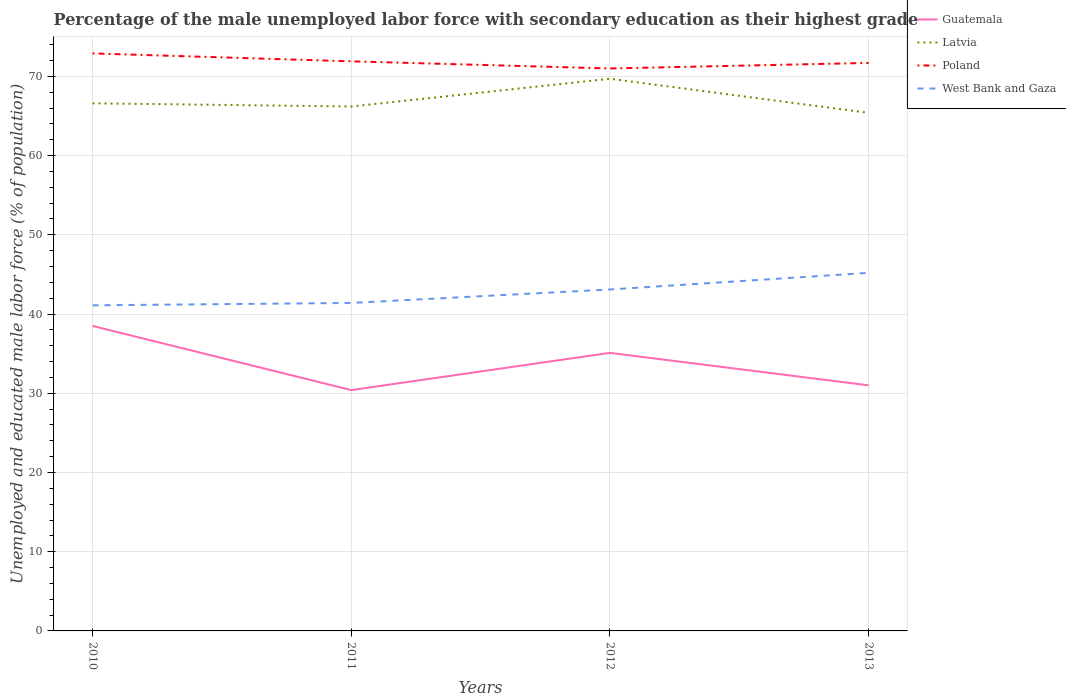Is the number of lines equal to the number of legend labels?
Offer a very short reply. Yes. Across all years, what is the maximum percentage of the unemployed male labor force with secondary education in Guatemala?
Your answer should be very brief. 30.4. What is the total percentage of the unemployed male labor force with secondary education in West Bank and Gaza in the graph?
Your answer should be very brief. -1.7. What is the difference between the highest and the second highest percentage of the unemployed male labor force with secondary education in Poland?
Provide a short and direct response. 1.9. What is the difference between the highest and the lowest percentage of the unemployed male labor force with secondary education in Guatemala?
Your answer should be compact. 2. How many lines are there?
Your answer should be very brief. 4. What is the difference between two consecutive major ticks on the Y-axis?
Provide a short and direct response. 10. Does the graph contain any zero values?
Keep it short and to the point. No. Does the graph contain grids?
Keep it short and to the point. Yes. How many legend labels are there?
Keep it short and to the point. 4. What is the title of the graph?
Your response must be concise. Percentage of the male unemployed labor force with secondary education as their highest grade. Does "Togo" appear as one of the legend labels in the graph?
Make the answer very short. No. What is the label or title of the X-axis?
Keep it short and to the point. Years. What is the label or title of the Y-axis?
Offer a terse response. Unemployed and educated male labor force (% of population). What is the Unemployed and educated male labor force (% of population) of Guatemala in 2010?
Provide a short and direct response. 38.5. What is the Unemployed and educated male labor force (% of population) in Latvia in 2010?
Provide a short and direct response. 66.6. What is the Unemployed and educated male labor force (% of population) of Poland in 2010?
Your response must be concise. 72.9. What is the Unemployed and educated male labor force (% of population) of West Bank and Gaza in 2010?
Make the answer very short. 41.1. What is the Unemployed and educated male labor force (% of population) in Guatemala in 2011?
Provide a succinct answer. 30.4. What is the Unemployed and educated male labor force (% of population) of Latvia in 2011?
Provide a succinct answer. 66.2. What is the Unemployed and educated male labor force (% of population) of Poland in 2011?
Offer a terse response. 71.9. What is the Unemployed and educated male labor force (% of population) of West Bank and Gaza in 2011?
Your answer should be compact. 41.4. What is the Unemployed and educated male labor force (% of population) in Guatemala in 2012?
Ensure brevity in your answer.  35.1. What is the Unemployed and educated male labor force (% of population) in Latvia in 2012?
Provide a short and direct response. 69.7. What is the Unemployed and educated male labor force (% of population) in Poland in 2012?
Make the answer very short. 71. What is the Unemployed and educated male labor force (% of population) of West Bank and Gaza in 2012?
Your answer should be compact. 43.1. What is the Unemployed and educated male labor force (% of population) in Latvia in 2013?
Offer a terse response. 65.4. What is the Unemployed and educated male labor force (% of population) of Poland in 2013?
Provide a succinct answer. 71.7. What is the Unemployed and educated male labor force (% of population) of West Bank and Gaza in 2013?
Give a very brief answer. 45.2. Across all years, what is the maximum Unemployed and educated male labor force (% of population) of Guatemala?
Offer a very short reply. 38.5. Across all years, what is the maximum Unemployed and educated male labor force (% of population) of Latvia?
Your answer should be compact. 69.7. Across all years, what is the maximum Unemployed and educated male labor force (% of population) of Poland?
Offer a terse response. 72.9. Across all years, what is the maximum Unemployed and educated male labor force (% of population) in West Bank and Gaza?
Offer a terse response. 45.2. Across all years, what is the minimum Unemployed and educated male labor force (% of population) in Guatemala?
Your response must be concise. 30.4. Across all years, what is the minimum Unemployed and educated male labor force (% of population) in Latvia?
Provide a short and direct response. 65.4. Across all years, what is the minimum Unemployed and educated male labor force (% of population) in West Bank and Gaza?
Keep it short and to the point. 41.1. What is the total Unemployed and educated male labor force (% of population) in Guatemala in the graph?
Keep it short and to the point. 135. What is the total Unemployed and educated male labor force (% of population) in Latvia in the graph?
Offer a very short reply. 267.9. What is the total Unemployed and educated male labor force (% of population) in Poland in the graph?
Provide a short and direct response. 287.5. What is the total Unemployed and educated male labor force (% of population) of West Bank and Gaza in the graph?
Your answer should be very brief. 170.8. What is the difference between the Unemployed and educated male labor force (% of population) of Poland in 2010 and that in 2011?
Provide a short and direct response. 1. What is the difference between the Unemployed and educated male labor force (% of population) in West Bank and Gaza in 2010 and that in 2011?
Your response must be concise. -0.3. What is the difference between the Unemployed and educated male labor force (% of population) of West Bank and Gaza in 2010 and that in 2012?
Your answer should be compact. -2. What is the difference between the Unemployed and educated male labor force (% of population) in Guatemala in 2010 and that in 2013?
Ensure brevity in your answer.  7.5. What is the difference between the Unemployed and educated male labor force (% of population) in Poland in 2010 and that in 2013?
Make the answer very short. 1.2. What is the difference between the Unemployed and educated male labor force (% of population) in West Bank and Gaza in 2010 and that in 2013?
Your answer should be very brief. -4.1. What is the difference between the Unemployed and educated male labor force (% of population) in Latvia in 2011 and that in 2012?
Offer a very short reply. -3.5. What is the difference between the Unemployed and educated male labor force (% of population) in West Bank and Gaza in 2011 and that in 2012?
Give a very brief answer. -1.7. What is the difference between the Unemployed and educated male labor force (% of population) in Poland in 2011 and that in 2013?
Your response must be concise. 0.2. What is the difference between the Unemployed and educated male labor force (% of population) in Guatemala in 2012 and that in 2013?
Make the answer very short. 4.1. What is the difference between the Unemployed and educated male labor force (% of population) of Poland in 2012 and that in 2013?
Provide a succinct answer. -0.7. What is the difference between the Unemployed and educated male labor force (% of population) of Guatemala in 2010 and the Unemployed and educated male labor force (% of population) of Latvia in 2011?
Your answer should be very brief. -27.7. What is the difference between the Unemployed and educated male labor force (% of population) in Guatemala in 2010 and the Unemployed and educated male labor force (% of population) in Poland in 2011?
Ensure brevity in your answer.  -33.4. What is the difference between the Unemployed and educated male labor force (% of population) in Guatemala in 2010 and the Unemployed and educated male labor force (% of population) in West Bank and Gaza in 2011?
Provide a short and direct response. -2.9. What is the difference between the Unemployed and educated male labor force (% of population) in Latvia in 2010 and the Unemployed and educated male labor force (% of population) in West Bank and Gaza in 2011?
Provide a succinct answer. 25.2. What is the difference between the Unemployed and educated male labor force (% of population) in Poland in 2010 and the Unemployed and educated male labor force (% of population) in West Bank and Gaza in 2011?
Ensure brevity in your answer.  31.5. What is the difference between the Unemployed and educated male labor force (% of population) of Guatemala in 2010 and the Unemployed and educated male labor force (% of population) of Latvia in 2012?
Keep it short and to the point. -31.2. What is the difference between the Unemployed and educated male labor force (% of population) of Guatemala in 2010 and the Unemployed and educated male labor force (% of population) of Poland in 2012?
Offer a very short reply. -32.5. What is the difference between the Unemployed and educated male labor force (% of population) of Guatemala in 2010 and the Unemployed and educated male labor force (% of population) of West Bank and Gaza in 2012?
Give a very brief answer. -4.6. What is the difference between the Unemployed and educated male labor force (% of population) of Poland in 2010 and the Unemployed and educated male labor force (% of population) of West Bank and Gaza in 2012?
Keep it short and to the point. 29.8. What is the difference between the Unemployed and educated male labor force (% of population) of Guatemala in 2010 and the Unemployed and educated male labor force (% of population) of Latvia in 2013?
Your response must be concise. -26.9. What is the difference between the Unemployed and educated male labor force (% of population) of Guatemala in 2010 and the Unemployed and educated male labor force (% of population) of Poland in 2013?
Your response must be concise. -33.2. What is the difference between the Unemployed and educated male labor force (% of population) of Guatemala in 2010 and the Unemployed and educated male labor force (% of population) of West Bank and Gaza in 2013?
Provide a succinct answer. -6.7. What is the difference between the Unemployed and educated male labor force (% of population) in Latvia in 2010 and the Unemployed and educated male labor force (% of population) in Poland in 2013?
Ensure brevity in your answer.  -5.1. What is the difference between the Unemployed and educated male labor force (% of population) in Latvia in 2010 and the Unemployed and educated male labor force (% of population) in West Bank and Gaza in 2013?
Ensure brevity in your answer.  21.4. What is the difference between the Unemployed and educated male labor force (% of population) in Poland in 2010 and the Unemployed and educated male labor force (% of population) in West Bank and Gaza in 2013?
Provide a short and direct response. 27.7. What is the difference between the Unemployed and educated male labor force (% of population) of Guatemala in 2011 and the Unemployed and educated male labor force (% of population) of Latvia in 2012?
Your response must be concise. -39.3. What is the difference between the Unemployed and educated male labor force (% of population) of Guatemala in 2011 and the Unemployed and educated male labor force (% of population) of Poland in 2012?
Your answer should be very brief. -40.6. What is the difference between the Unemployed and educated male labor force (% of population) in Latvia in 2011 and the Unemployed and educated male labor force (% of population) in West Bank and Gaza in 2012?
Your response must be concise. 23.1. What is the difference between the Unemployed and educated male labor force (% of population) in Poland in 2011 and the Unemployed and educated male labor force (% of population) in West Bank and Gaza in 2012?
Provide a short and direct response. 28.8. What is the difference between the Unemployed and educated male labor force (% of population) in Guatemala in 2011 and the Unemployed and educated male labor force (% of population) in Latvia in 2013?
Provide a short and direct response. -35. What is the difference between the Unemployed and educated male labor force (% of population) of Guatemala in 2011 and the Unemployed and educated male labor force (% of population) of Poland in 2013?
Your answer should be compact. -41.3. What is the difference between the Unemployed and educated male labor force (% of population) in Guatemala in 2011 and the Unemployed and educated male labor force (% of population) in West Bank and Gaza in 2013?
Make the answer very short. -14.8. What is the difference between the Unemployed and educated male labor force (% of population) in Latvia in 2011 and the Unemployed and educated male labor force (% of population) in West Bank and Gaza in 2013?
Offer a terse response. 21. What is the difference between the Unemployed and educated male labor force (% of population) in Poland in 2011 and the Unemployed and educated male labor force (% of population) in West Bank and Gaza in 2013?
Your answer should be very brief. 26.7. What is the difference between the Unemployed and educated male labor force (% of population) of Guatemala in 2012 and the Unemployed and educated male labor force (% of population) of Latvia in 2013?
Your answer should be very brief. -30.3. What is the difference between the Unemployed and educated male labor force (% of population) in Guatemala in 2012 and the Unemployed and educated male labor force (% of population) in Poland in 2013?
Make the answer very short. -36.6. What is the difference between the Unemployed and educated male labor force (% of population) of Poland in 2012 and the Unemployed and educated male labor force (% of population) of West Bank and Gaza in 2013?
Ensure brevity in your answer.  25.8. What is the average Unemployed and educated male labor force (% of population) of Guatemala per year?
Provide a short and direct response. 33.75. What is the average Unemployed and educated male labor force (% of population) in Latvia per year?
Give a very brief answer. 66.97. What is the average Unemployed and educated male labor force (% of population) of Poland per year?
Give a very brief answer. 71.88. What is the average Unemployed and educated male labor force (% of population) of West Bank and Gaza per year?
Ensure brevity in your answer.  42.7. In the year 2010, what is the difference between the Unemployed and educated male labor force (% of population) in Guatemala and Unemployed and educated male labor force (% of population) in Latvia?
Give a very brief answer. -28.1. In the year 2010, what is the difference between the Unemployed and educated male labor force (% of population) in Guatemala and Unemployed and educated male labor force (% of population) in Poland?
Your answer should be compact. -34.4. In the year 2010, what is the difference between the Unemployed and educated male labor force (% of population) in Guatemala and Unemployed and educated male labor force (% of population) in West Bank and Gaza?
Offer a very short reply. -2.6. In the year 2010, what is the difference between the Unemployed and educated male labor force (% of population) of Latvia and Unemployed and educated male labor force (% of population) of West Bank and Gaza?
Your response must be concise. 25.5. In the year 2010, what is the difference between the Unemployed and educated male labor force (% of population) in Poland and Unemployed and educated male labor force (% of population) in West Bank and Gaza?
Provide a short and direct response. 31.8. In the year 2011, what is the difference between the Unemployed and educated male labor force (% of population) of Guatemala and Unemployed and educated male labor force (% of population) of Latvia?
Make the answer very short. -35.8. In the year 2011, what is the difference between the Unemployed and educated male labor force (% of population) in Guatemala and Unemployed and educated male labor force (% of population) in Poland?
Ensure brevity in your answer.  -41.5. In the year 2011, what is the difference between the Unemployed and educated male labor force (% of population) of Guatemala and Unemployed and educated male labor force (% of population) of West Bank and Gaza?
Offer a terse response. -11. In the year 2011, what is the difference between the Unemployed and educated male labor force (% of population) in Latvia and Unemployed and educated male labor force (% of population) in West Bank and Gaza?
Provide a short and direct response. 24.8. In the year 2011, what is the difference between the Unemployed and educated male labor force (% of population) of Poland and Unemployed and educated male labor force (% of population) of West Bank and Gaza?
Provide a short and direct response. 30.5. In the year 2012, what is the difference between the Unemployed and educated male labor force (% of population) of Guatemala and Unemployed and educated male labor force (% of population) of Latvia?
Your answer should be compact. -34.6. In the year 2012, what is the difference between the Unemployed and educated male labor force (% of population) in Guatemala and Unemployed and educated male labor force (% of population) in Poland?
Provide a succinct answer. -35.9. In the year 2012, what is the difference between the Unemployed and educated male labor force (% of population) in Latvia and Unemployed and educated male labor force (% of population) in Poland?
Make the answer very short. -1.3. In the year 2012, what is the difference between the Unemployed and educated male labor force (% of population) of Latvia and Unemployed and educated male labor force (% of population) of West Bank and Gaza?
Ensure brevity in your answer.  26.6. In the year 2012, what is the difference between the Unemployed and educated male labor force (% of population) of Poland and Unemployed and educated male labor force (% of population) of West Bank and Gaza?
Your answer should be compact. 27.9. In the year 2013, what is the difference between the Unemployed and educated male labor force (% of population) in Guatemala and Unemployed and educated male labor force (% of population) in Latvia?
Provide a short and direct response. -34.4. In the year 2013, what is the difference between the Unemployed and educated male labor force (% of population) of Guatemala and Unemployed and educated male labor force (% of population) of Poland?
Your response must be concise. -40.7. In the year 2013, what is the difference between the Unemployed and educated male labor force (% of population) of Latvia and Unemployed and educated male labor force (% of population) of West Bank and Gaza?
Your response must be concise. 20.2. In the year 2013, what is the difference between the Unemployed and educated male labor force (% of population) in Poland and Unemployed and educated male labor force (% of population) in West Bank and Gaza?
Ensure brevity in your answer.  26.5. What is the ratio of the Unemployed and educated male labor force (% of population) of Guatemala in 2010 to that in 2011?
Offer a very short reply. 1.27. What is the ratio of the Unemployed and educated male labor force (% of population) in Latvia in 2010 to that in 2011?
Provide a succinct answer. 1.01. What is the ratio of the Unemployed and educated male labor force (% of population) in Poland in 2010 to that in 2011?
Make the answer very short. 1.01. What is the ratio of the Unemployed and educated male labor force (% of population) in West Bank and Gaza in 2010 to that in 2011?
Your response must be concise. 0.99. What is the ratio of the Unemployed and educated male labor force (% of population) in Guatemala in 2010 to that in 2012?
Offer a very short reply. 1.1. What is the ratio of the Unemployed and educated male labor force (% of population) of Latvia in 2010 to that in 2012?
Your answer should be very brief. 0.96. What is the ratio of the Unemployed and educated male labor force (% of population) of Poland in 2010 to that in 2012?
Provide a succinct answer. 1.03. What is the ratio of the Unemployed and educated male labor force (% of population) of West Bank and Gaza in 2010 to that in 2012?
Provide a succinct answer. 0.95. What is the ratio of the Unemployed and educated male labor force (% of population) of Guatemala in 2010 to that in 2013?
Your response must be concise. 1.24. What is the ratio of the Unemployed and educated male labor force (% of population) in Latvia in 2010 to that in 2013?
Give a very brief answer. 1.02. What is the ratio of the Unemployed and educated male labor force (% of population) in Poland in 2010 to that in 2013?
Ensure brevity in your answer.  1.02. What is the ratio of the Unemployed and educated male labor force (% of population) of West Bank and Gaza in 2010 to that in 2013?
Give a very brief answer. 0.91. What is the ratio of the Unemployed and educated male labor force (% of population) in Guatemala in 2011 to that in 2012?
Your answer should be compact. 0.87. What is the ratio of the Unemployed and educated male labor force (% of population) in Latvia in 2011 to that in 2012?
Ensure brevity in your answer.  0.95. What is the ratio of the Unemployed and educated male labor force (% of population) in Poland in 2011 to that in 2012?
Provide a succinct answer. 1.01. What is the ratio of the Unemployed and educated male labor force (% of population) in West Bank and Gaza in 2011 to that in 2012?
Provide a short and direct response. 0.96. What is the ratio of the Unemployed and educated male labor force (% of population) of Guatemala in 2011 to that in 2013?
Keep it short and to the point. 0.98. What is the ratio of the Unemployed and educated male labor force (% of population) in Latvia in 2011 to that in 2013?
Ensure brevity in your answer.  1.01. What is the ratio of the Unemployed and educated male labor force (% of population) of West Bank and Gaza in 2011 to that in 2013?
Offer a very short reply. 0.92. What is the ratio of the Unemployed and educated male labor force (% of population) of Guatemala in 2012 to that in 2013?
Give a very brief answer. 1.13. What is the ratio of the Unemployed and educated male labor force (% of population) in Latvia in 2012 to that in 2013?
Give a very brief answer. 1.07. What is the ratio of the Unemployed and educated male labor force (% of population) of Poland in 2012 to that in 2013?
Give a very brief answer. 0.99. What is the ratio of the Unemployed and educated male labor force (% of population) of West Bank and Gaza in 2012 to that in 2013?
Ensure brevity in your answer.  0.95. What is the difference between the highest and the second highest Unemployed and educated male labor force (% of population) in Guatemala?
Offer a very short reply. 3.4. What is the difference between the highest and the second highest Unemployed and educated male labor force (% of population) of Latvia?
Provide a succinct answer. 3.1. What is the difference between the highest and the lowest Unemployed and educated male labor force (% of population) in Poland?
Make the answer very short. 1.9. What is the difference between the highest and the lowest Unemployed and educated male labor force (% of population) in West Bank and Gaza?
Your answer should be compact. 4.1. 